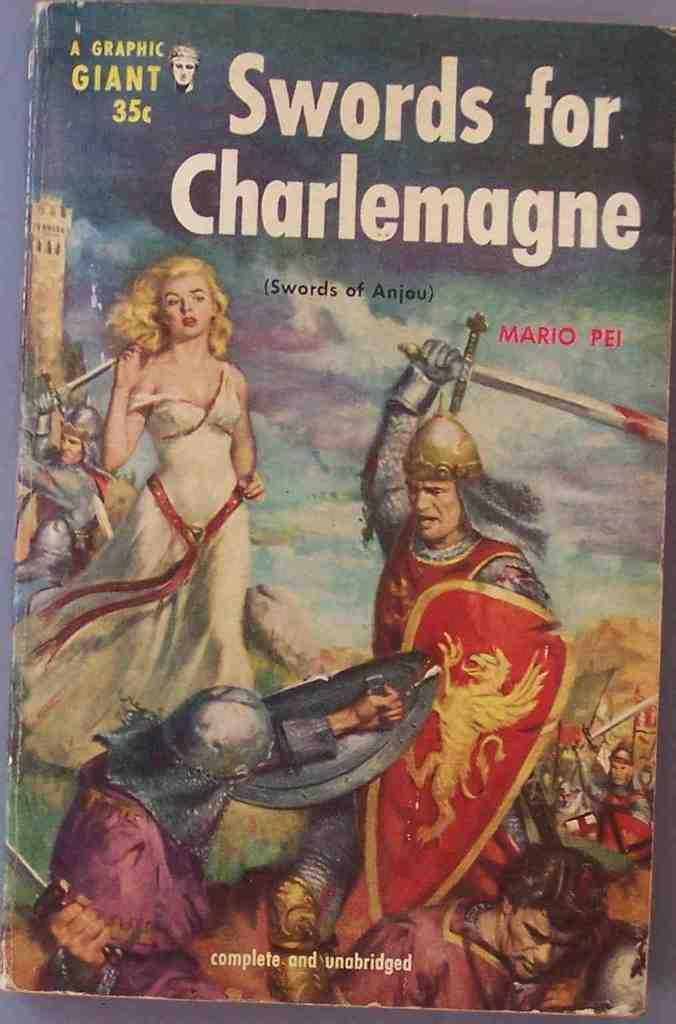<image>
Offer a succinct explanation of the picture presented. Book named Swords for Charlemagne with a cover showing a warrior attacking someone. 